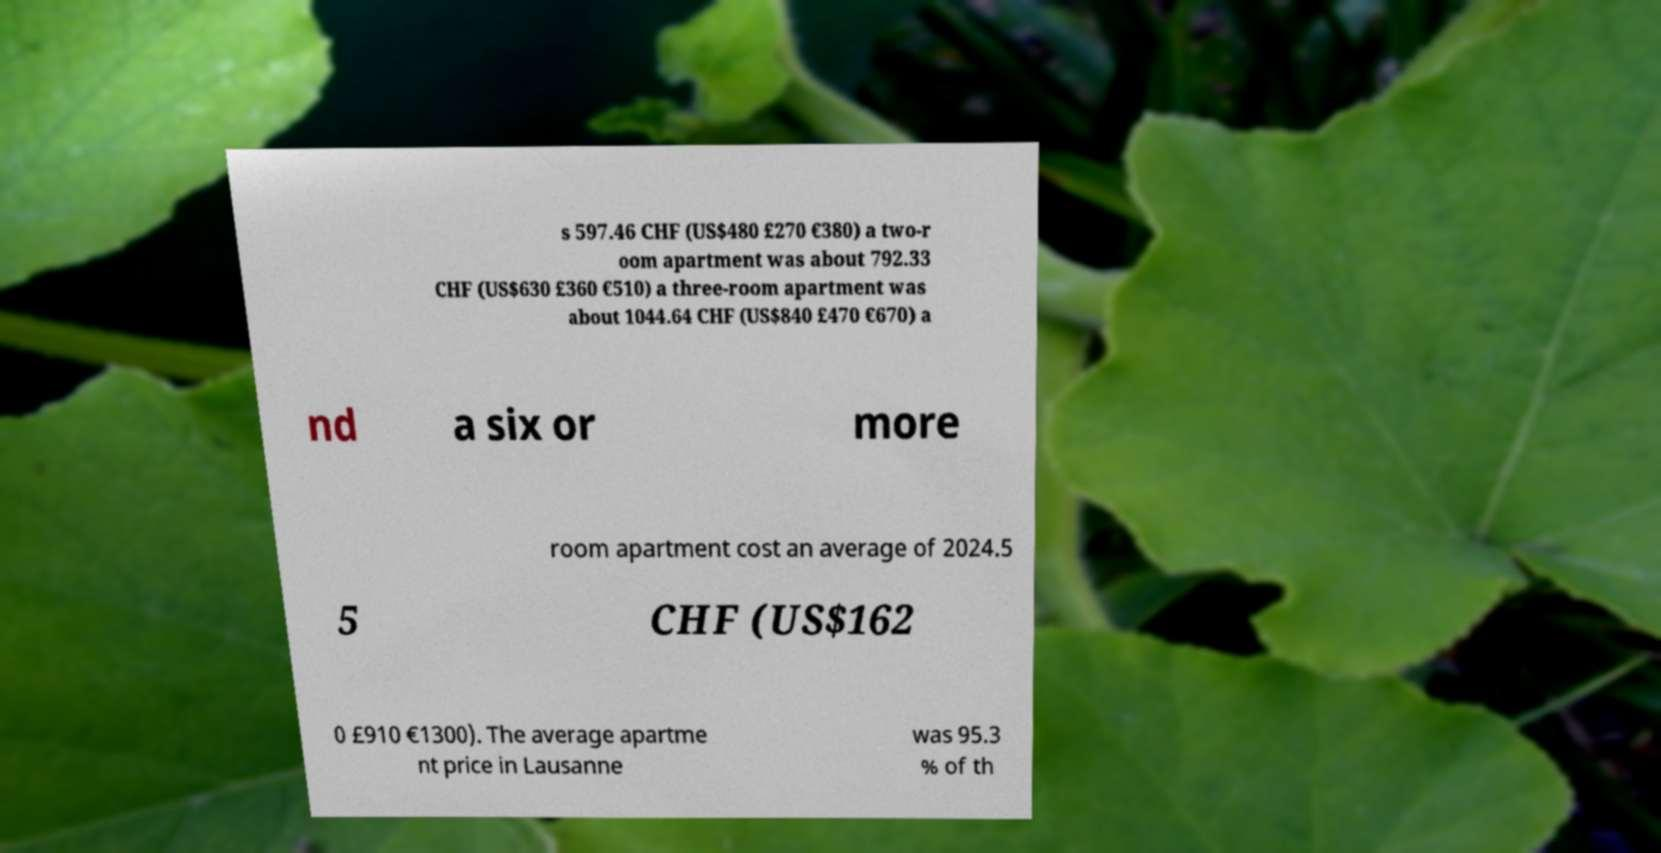Could you assist in decoding the text presented in this image and type it out clearly? s 597.46 CHF (US$480 £270 €380) a two-r oom apartment was about 792.33 CHF (US$630 £360 €510) a three-room apartment was about 1044.64 CHF (US$840 £470 €670) a nd a six or more room apartment cost an average of 2024.5 5 CHF (US$162 0 £910 €1300). The average apartme nt price in Lausanne was 95.3 % of th 